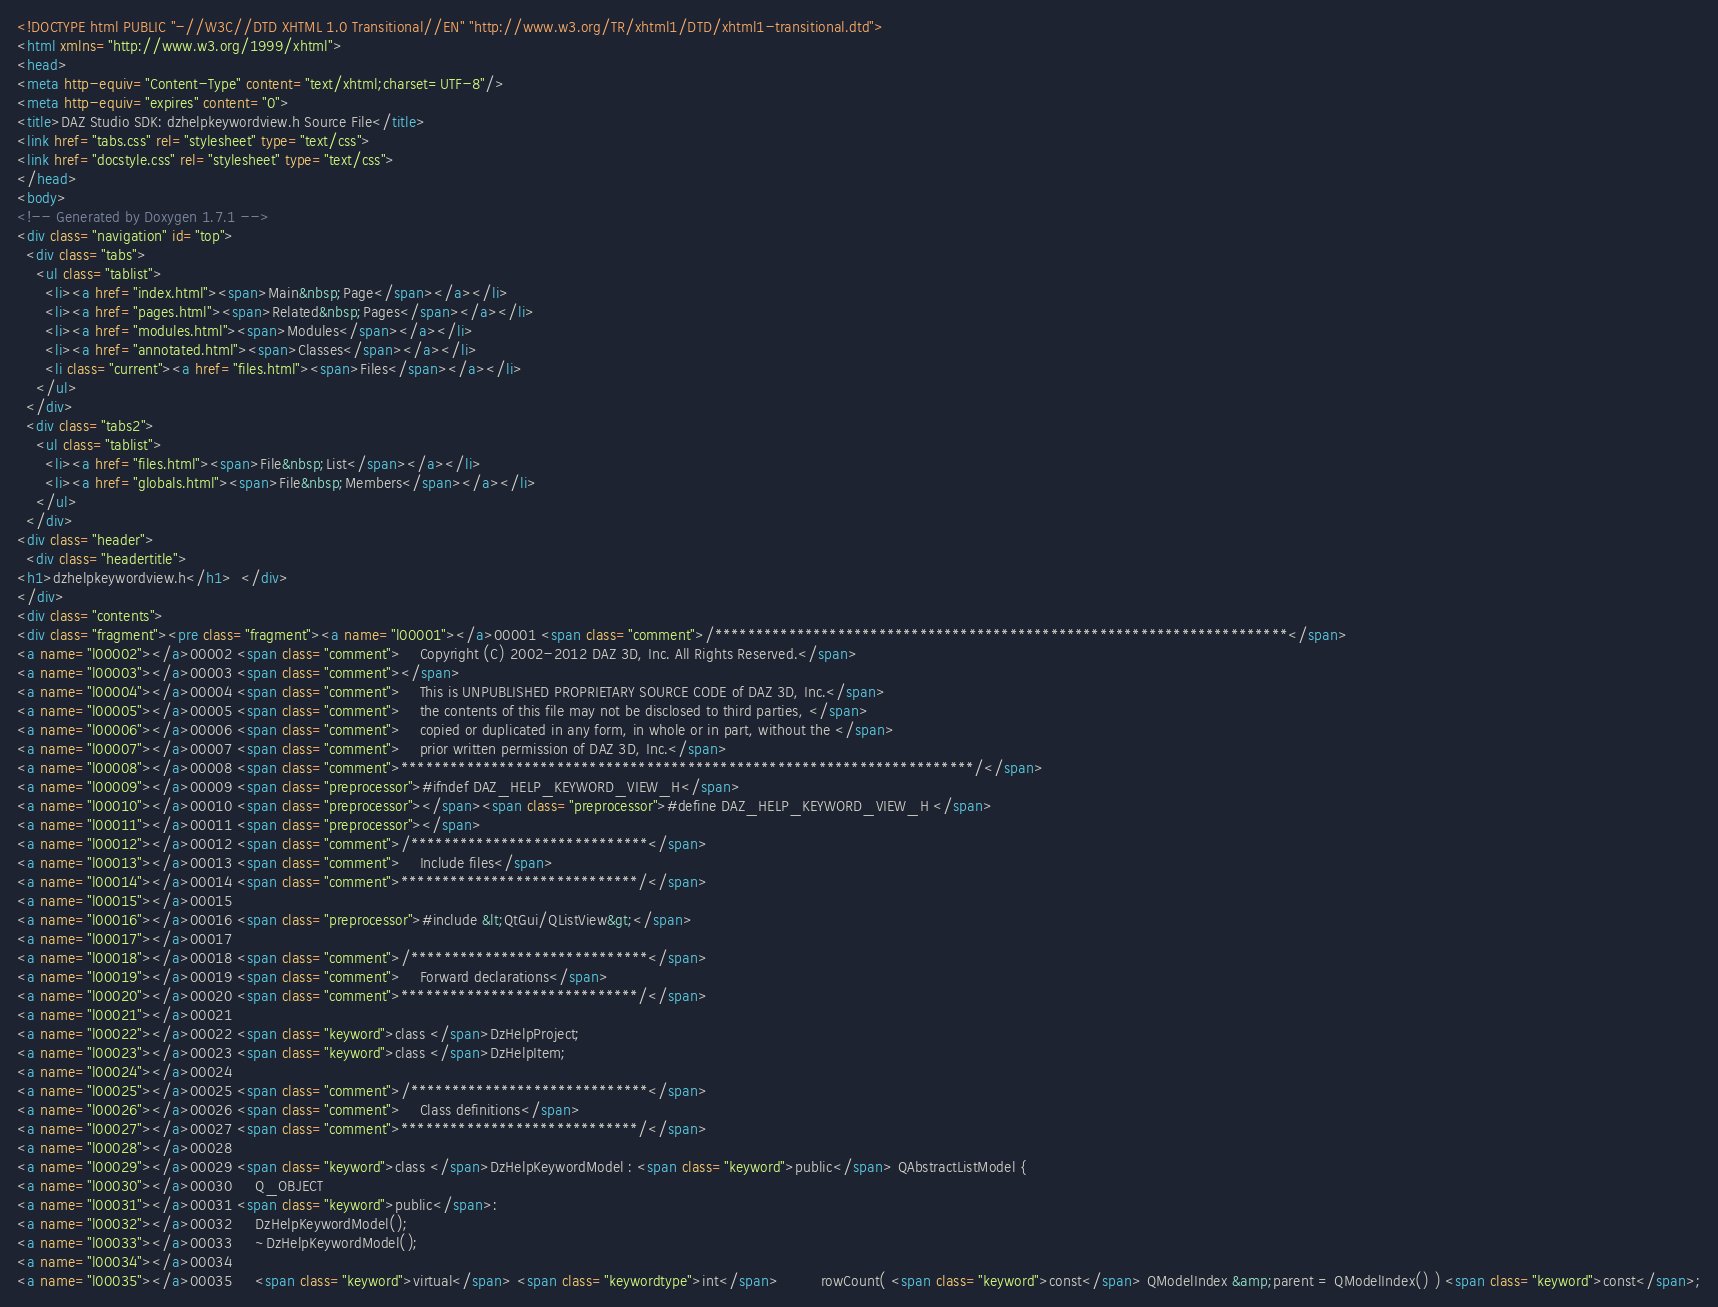<code> <loc_0><loc_0><loc_500><loc_500><_HTML_><!DOCTYPE html PUBLIC "-//W3C//DTD XHTML 1.0 Transitional//EN" "http://www.w3.org/TR/xhtml1/DTD/xhtml1-transitional.dtd">
<html xmlns="http://www.w3.org/1999/xhtml">
<head>
<meta http-equiv="Content-Type" content="text/xhtml;charset=UTF-8"/>
<meta http-equiv="expires" content="0">
<title>DAZ Studio SDK: dzhelpkeywordview.h Source File</title>
<link href="tabs.css" rel="stylesheet" type="text/css">
<link href="docstyle.css" rel="stylesheet" type="text/css">
</head>
<body>
<!-- Generated by Doxygen 1.7.1 -->
<div class="navigation" id="top">
  <div class="tabs">
    <ul class="tablist">
      <li><a href="index.html"><span>Main&nbsp;Page</span></a></li>
      <li><a href="pages.html"><span>Related&nbsp;Pages</span></a></li>
      <li><a href="modules.html"><span>Modules</span></a></li>
      <li><a href="annotated.html"><span>Classes</span></a></li>
      <li class="current"><a href="files.html"><span>Files</span></a></li>
    </ul>
  </div>
  <div class="tabs2">
    <ul class="tablist">
      <li><a href="files.html"><span>File&nbsp;List</span></a></li>
      <li><a href="globals.html"><span>File&nbsp;Members</span></a></li>
    </ul>
  </div>
<div class="header">
  <div class="headertitle">
<h1>dzhelpkeywordview.h</h1>  </div>
</div>
<div class="contents">
<div class="fragment"><pre class="fragment"><a name="l00001"></a>00001 <span class="comment">/**********************************************************************</span>
<a name="l00002"></a>00002 <span class="comment">    Copyright (C) 2002-2012 DAZ 3D, Inc. All Rights Reserved.</span>
<a name="l00003"></a>00003 <span class="comment"></span>
<a name="l00004"></a>00004 <span class="comment">    This is UNPUBLISHED PROPRIETARY SOURCE CODE of DAZ 3D, Inc.</span>
<a name="l00005"></a>00005 <span class="comment">    the contents of this file may not be disclosed to third parties, </span>
<a name="l00006"></a>00006 <span class="comment">    copied or duplicated in any form, in whole or in part, without the </span>
<a name="l00007"></a>00007 <span class="comment">    prior written permission of DAZ 3D, Inc.</span>
<a name="l00008"></a>00008 <span class="comment">**********************************************************************/</span>
<a name="l00009"></a>00009 <span class="preprocessor">#ifndef DAZ_HELP_KEYWORD_VIEW_H</span>
<a name="l00010"></a>00010 <span class="preprocessor"></span><span class="preprocessor">#define DAZ_HELP_KEYWORD_VIEW_H </span>
<a name="l00011"></a>00011 <span class="preprocessor"></span>
<a name="l00012"></a>00012 <span class="comment">/*****************************</span>
<a name="l00013"></a>00013 <span class="comment">    Include files</span>
<a name="l00014"></a>00014 <span class="comment">*****************************/</span>
<a name="l00015"></a>00015 
<a name="l00016"></a>00016 <span class="preprocessor">#include &lt;QtGui/QListView&gt;</span>
<a name="l00017"></a>00017 
<a name="l00018"></a>00018 <span class="comment">/*****************************</span>
<a name="l00019"></a>00019 <span class="comment">    Forward declarations</span>
<a name="l00020"></a>00020 <span class="comment">*****************************/</span>
<a name="l00021"></a>00021 
<a name="l00022"></a>00022 <span class="keyword">class </span>DzHelpProject;
<a name="l00023"></a>00023 <span class="keyword">class </span>DzHelpItem;
<a name="l00024"></a>00024 
<a name="l00025"></a>00025 <span class="comment">/*****************************</span>
<a name="l00026"></a>00026 <span class="comment">    Class definitions</span>
<a name="l00027"></a>00027 <span class="comment">*****************************/</span>
<a name="l00028"></a>00028 
<a name="l00029"></a>00029 <span class="keyword">class </span>DzHelpKeywordModel : <span class="keyword">public</span> QAbstractListModel {
<a name="l00030"></a>00030     Q_OBJECT
<a name="l00031"></a>00031 <span class="keyword">public</span>:
<a name="l00032"></a>00032     DzHelpKeywordModel();
<a name="l00033"></a>00033     ~DzHelpKeywordModel();
<a name="l00034"></a>00034 
<a name="l00035"></a>00035     <span class="keyword">virtual</span> <span class="keywordtype">int</span>         rowCount( <span class="keyword">const</span> QModelIndex &amp;parent = QModelIndex() ) <span class="keyword">const</span>;</code> 